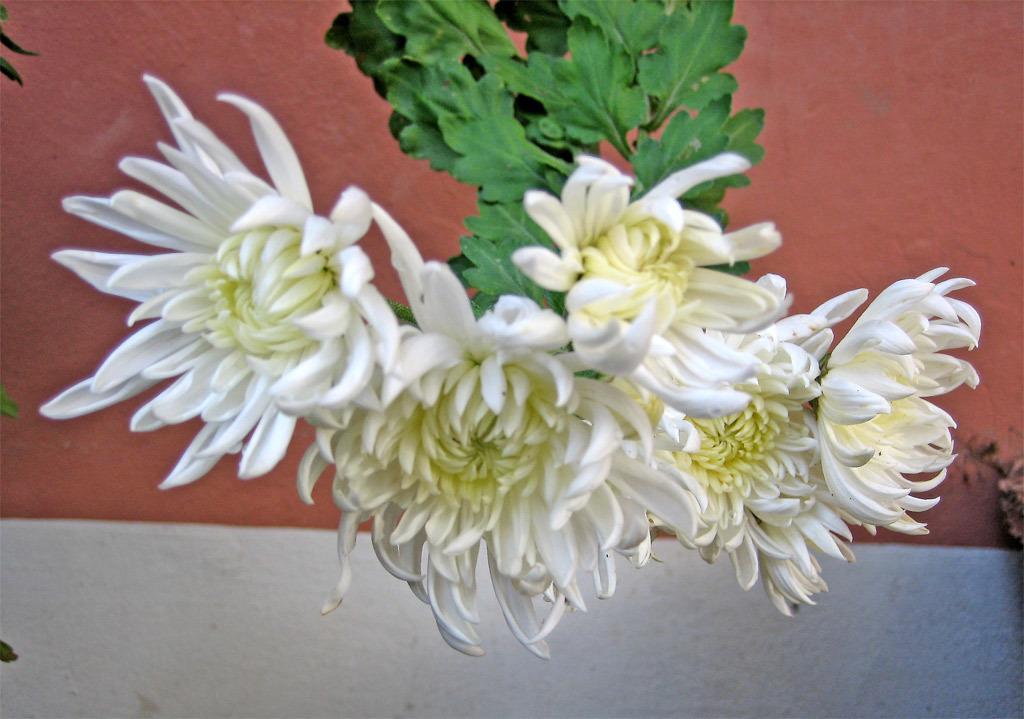Please provide a concise description of this image. This image consists of white color flowers along with green leaves. In the background, there is wall in red and white color. 